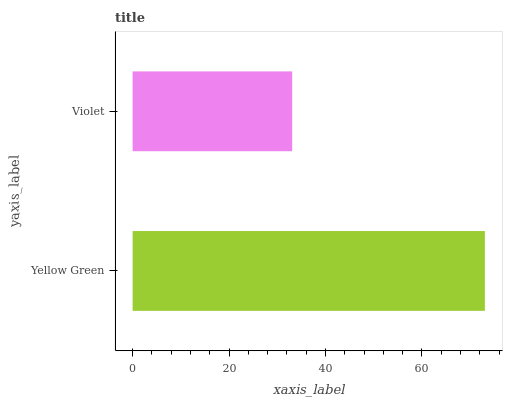Is Violet the minimum?
Answer yes or no. Yes. Is Yellow Green the maximum?
Answer yes or no. Yes. Is Violet the maximum?
Answer yes or no. No. Is Yellow Green greater than Violet?
Answer yes or no. Yes. Is Violet less than Yellow Green?
Answer yes or no. Yes. Is Violet greater than Yellow Green?
Answer yes or no. No. Is Yellow Green less than Violet?
Answer yes or no. No. Is Yellow Green the high median?
Answer yes or no. Yes. Is Violet the low median?
Answer yes or no. Yes. Is Violet the high median?
Answer yes or no. No. Is Yellow Green the low median?
Answer yes or no. No. 